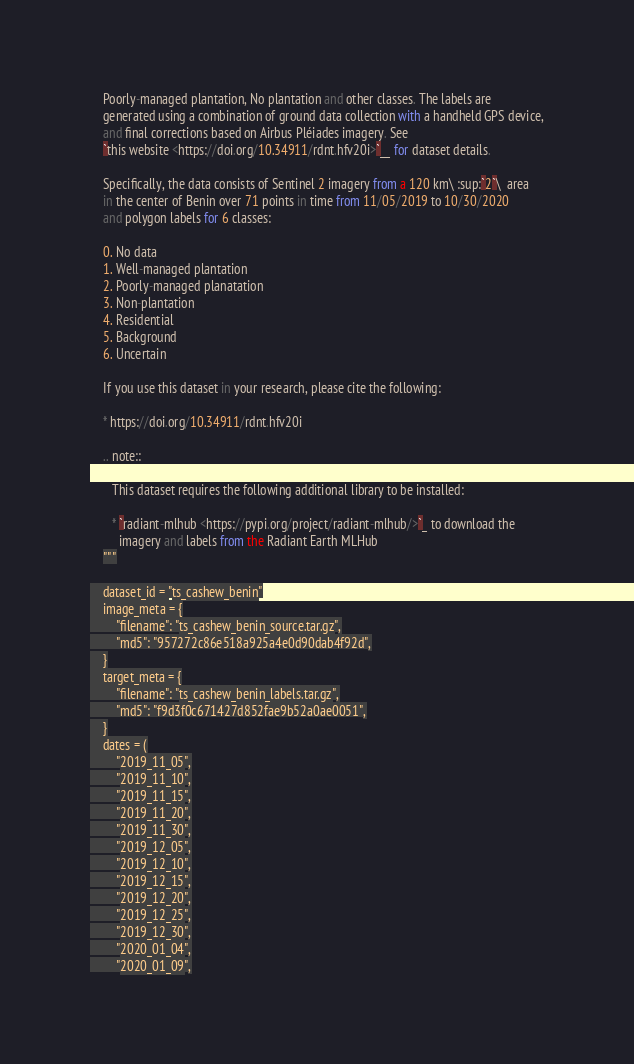Convert code to text. <code><loc_0><loc_0><loc_500><loc_500><_Python_>    Poorly-managed plantation, No plantation and other classes. The labels are
    generated using a combination of ground data collection with a handheld GPS device,
    and final corrections based on Airbus Pléiades imagery. See
    `this website <https://doi.org/10.34911/rdnt.hfv20i>`__ for dataset details.

    Specifically, the data consists of Sentinel 2 imagery from a 120 km\ :sup:`2`\  area
    in the center of Benin over 71 points in time from 11/05/2019 to 10/30/2020
    and polygon labels for 6 classes:

    0. No data
    1. Well-managed plantation
    2. Poorly-managed planatation
    3. Non-plantation
    4. Residential
    5. Background
    6. Uncertain

    If you use this dataset in your research, please cite the following:

    * https://doi.org/10.34911/rdnt.hfv20i

    .. note::

       This dataset requires the following additional library to be installed:

       * `radiant-mlhub <https://pypi.org/project/radiant-mlhub/>`_ to download the
         imagery and labels from the Radiant Earth MLHub
    """

    dataset_id = "ts_cashew_benin"
    image_meta = {
        "filename": "ts_cashew_benin_source.tar.gz",
        "md5": "957272c86e518a925a4e0d90dab4f92d",
    }
    target_meta = {
        "filename": "ts_cashew_benin_labels.tar.gz",
        "md5": "f9d3f0c671427d852fae9b52a0ae0051",
    }
    dates = (
        "2019_11_05",
        "2019_11_10",
        "2019_11_15",
        "2019_11_20",
        "2019_11_30",
        "2019_12_05",
        "2019_12_10",
        "2019_12_15",
        "2019_12_20",
        "2019_12_25",
        "2019_12_30",
        "2020_01_04",
        "2020_01_09",</code> 